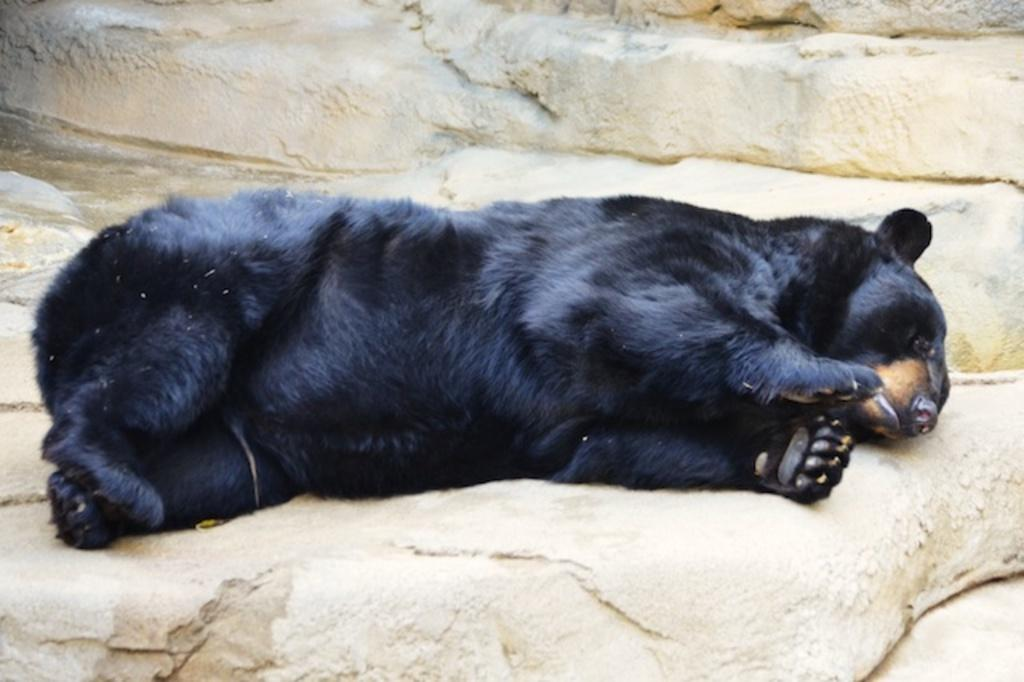What animal is in the foreground of the picture? There is a black bear in the foreground of the picture. What is the black bear doing in the picture? The black bear is lying on a rock. What type of test is the black bear taking in the picture? There is no test present in the image, and the black bear is not taking any test. What arithmetic problem is the black bear solving in the picture? There is no arithmetic problem present in the image, and the black bear is not solving any problem. 